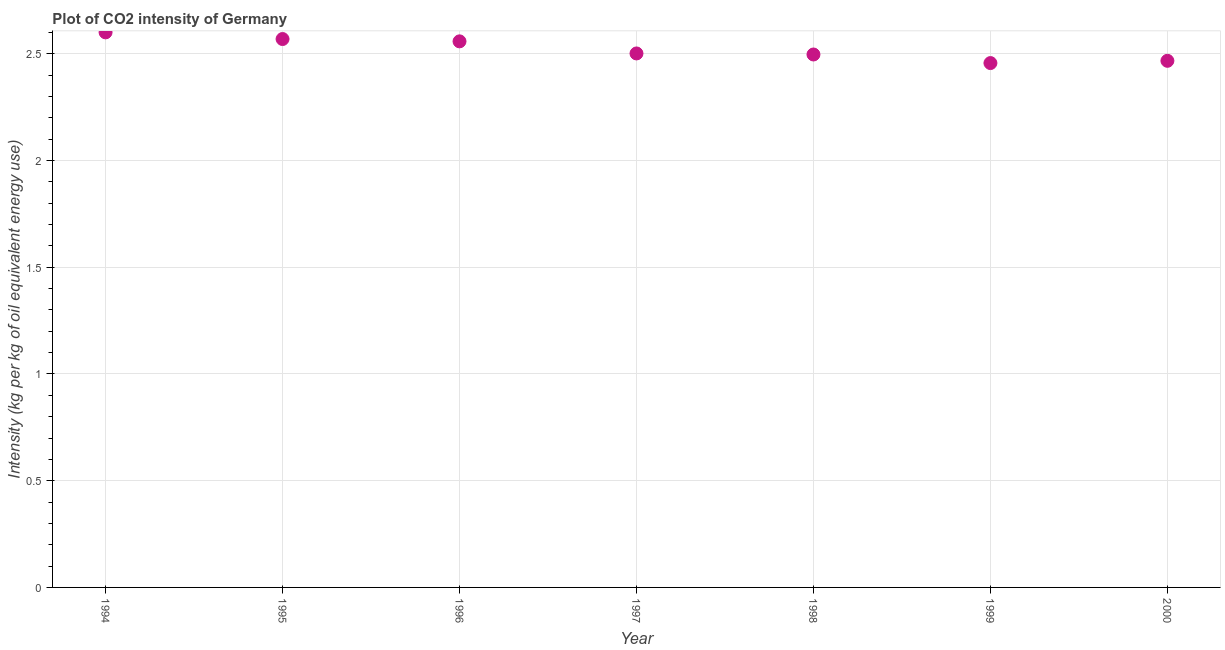What is the co2 intensity in 1999?
Your response must be concise. 2.46. Across all years, what is the maximum co2 intensity?
Offer a terse response. 2.6. Across all years, what is the minimum co2 intensity?
Provide a succinct answer. 2.46. In which year was the co2 intensity minimum?
Offer a terse response. 1999. What is the sum of the co2 intensity?
Ensure brevity in your answer.  17.65. What is the difference between the co2 intensity in 1995 and 2000?
Make the answer very short. 0.1. What is the average co2 intensity per year?
Offer a very short reply. 2.52. What is the median co2 intensity?
Provide a succinct answer. 2.5. In how many years, is the co2 intensity greater than 1.1 kg?
Your answer should be compact. 7. What is the ratio of the co2 intensity in 1997 to that in 1999?
Provide a succinct answer. 1.02. Is the co2 intensity in 1997 less than that in 2000?
Your answer should be compact. No. What is the difference between the highest and the second highest co2 intensity?
Offer a very short reply. 0.03. Is the sum of the co2 intensity in 1999 and 2000 greater than the maximum co2 intensity across all years?
Ensure brevity in your answer.  Yes. What is the difference between the highest and the lowest co2 intensity?
Provide a short and direct response. 0.14. In how many years, is the co2 intensity greater than the average co2 intensity taken over all years?
Offer a very short reply. 3. Does the co2 intensity monotonically increase over the years?
Make the answer very short. No. What is the title of the graph?
Provide a succinct answer. Plot of CO2 intensity of Germany. What is the label or title of the X-axis?
Your answer should be compact. Year. What is the label or title of the Y-axis?
Ensure brevity in your answer.  Intensity (kg per kg of oil equivalent energy use). What is the Intensity (kg per kg of oil equivalent energy use) in 1994?
Your response must be concise. 2.6. What is the Intensity (kg per kg of oil equivalent energy use) in 1995?
Your answer should be very brief. 2.57. What is the Intensity (kg per kg of oil equivalent energy use) in 1996?
Make the answer very short. 2.56. What is the Intensity (kg per kg of oil equivalent energy use) in 1997?
Your answer should be compact. 2.5. What is the Intensity (kg per kg of oil equivalent energy use) in 1998?
Keep it short and to the point. 2.5. What is the Intensity (kg per kg of oil equivalent energy use) in 1999?
Your answer should be very brief. 2.46. What is the Intensity (kg per kg of oil equivalent energy use) in 2000?
Your response must be concise. 2.47. What is the difference between the Intensity (kg per kg of oil equivalent energy use) in 1994 and 1995?
Your response must be concise. 0.03. What is the difference between the Intensity (kg per kg of oil equivalent energy use) in 1994 and 1996?
Ensure brevity in your answer.  0.04. What is the difference between the Intensity (kg per kg of oil equivalent energy use) in 1994 and 1997?
Your response must be concise. 0.1. What is the difference between the Intensity (kg per kg of oil equivalent energy use) in 1994 and 1998?
Ensure brevity in your answer.  0.1. What is the difference between the Intensity (kg per kg of oil equivalent energy use) in 1994 and 1999?
Provide a short and direct response. 0.14. What is the difference between the Intensity (kg per kg of oil equivalent energy use) in 1994 and 2000?
Offer a very short reply. 0.13. What is the difference between the Intensity (kg per kg of oil equivalent energy use) in 1995 and 1996?
Provide a short and direct response. 0.01. What is the difference between the Intensity (kg per kg of oil equivalent energy use) in 1995 and 1997?
Provide a succinct answer. 0.07. What is the difference between the Intensity (kg per kg of oil equivalent energy use) in 1995 and 1998?
Make the answer very short. 0.07. What is the difference between the Intensity (kg per kg of oil equivalent energy use) in 1995 and 1999?
Make the answer very short. 0.11. What is the difference between the Intensity (kg per kg of oil equivalent energy use) in 1995 and 2000?
Your response must be concise. 0.1. What is the difference between the Intensity (kg per kg of oil equivalent energy use) in 1996 and 1997?
Keep it short and to the point. 0.06. What is the difference between the Intensity (kg per kg of oil equivalent energy use) in 1996 and 1998?
Provide a short and direct response. 0.06. What is the difference between the Intensity (kg per kg of oil equivalent energy use) in 1996 and 1999?
Give a very brief answer. 0.1. What is the difference between the Intensity (kg per kg of oil equivalent energy use) in 1996 and 2000?
Provide a succinct answer. 0.09. What is the difference between the Intensity (kg per kg of oil equivalent energy use) in 1997 and 1998?
Keep it short and to the point. 0. What is the difference between the Intensity (kg per kg of oil equivalent energy use) in 1997 and 1999?
Your answer should be compact. 0.05. What is the difference between the Intensity (kg per kg of oil equivalent energy use) in 1997 and 2000?
Your answer should be compact. 0.03. What is the difference between the Intensity (kg per kg of oil equivalent energy use) in 1998 and 1999?
Provide a succinct answer. 0.04. What is the difference between the Intensity (kg per kg of oil equivalent energy use) in 1998 and 2000?
Keep it short and to the point. 0.03. What is the difference between the Intensity (kg per kg of oil equivalent energy use) in 1999 and 2000?
Your response must be concise. -0.01. What is the ratio of the Intensity (kg per kg of oil equivalent energy use) in 1994 to that in 1997?
Keep it short and to the point. 1.04. What is the ratio of the Intensity (kg per kg of oil equivalent energy use) in 1994 to that in 1998?
Your response must be concise. 1.04. What is the ratio of the Intensity (kg per kg of oil equivalent energy use) in 1994 to that in 1999?
Your answer should be very brief. 1.06. What is the ratio of the Intensity (kg per kg of oil equivalent energy use) in 1994 to that in 2000?
Give a very brief answer. 1.05. What is the ratio of the Intensity (kg per kg of oil equivalent energy use) in 1995 to that in 1999?
Keep it short and to the point. 1.05. What is the ratio of the Intensity (kg per kg of oil equivalent energy use) in 1995 to that in 2000?
Ensure brevity in your answer.  1.04. What is the ratio of the Intensity (kg per kg of oil equivalent energy use) in 1996 to that in 1997?
Your answer should be very brief. 1.02. What is the ratio of the Intensity (kg per kg of oil equivalent energy use) in 1996 to that in 1998?
Offer a very short reply. 1.02. What is the ratio of the Intensity (kg per kg of oil equivalent energy use) in 1996 to that in 1999?
Your response must be concise. 1.04. What is the ratio of the Intensity (kg per kg of oil equivalent energy use) in 1996 to that in 2000?
Your response must be concise. 1.04. What is the ratio of the Intensity (kg per kg of oil equivalent energy use) in 1997 to that in 1998?
Offer a terse response. 1. What is the ratio of the Intensity (kg per kg of oil equivalent energy use) in 1998 to that in 1999?
Make the answer very short. 1.02. 